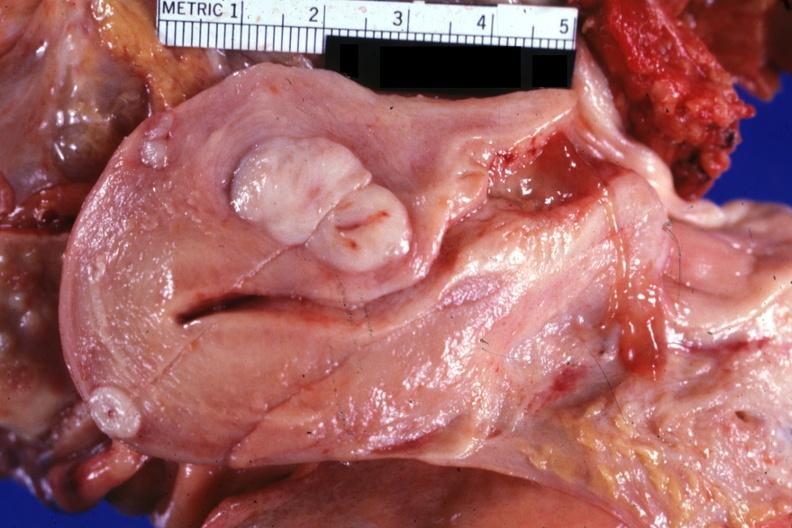s female reproductive present?
Answer the question using a single word or phrase. Yes 